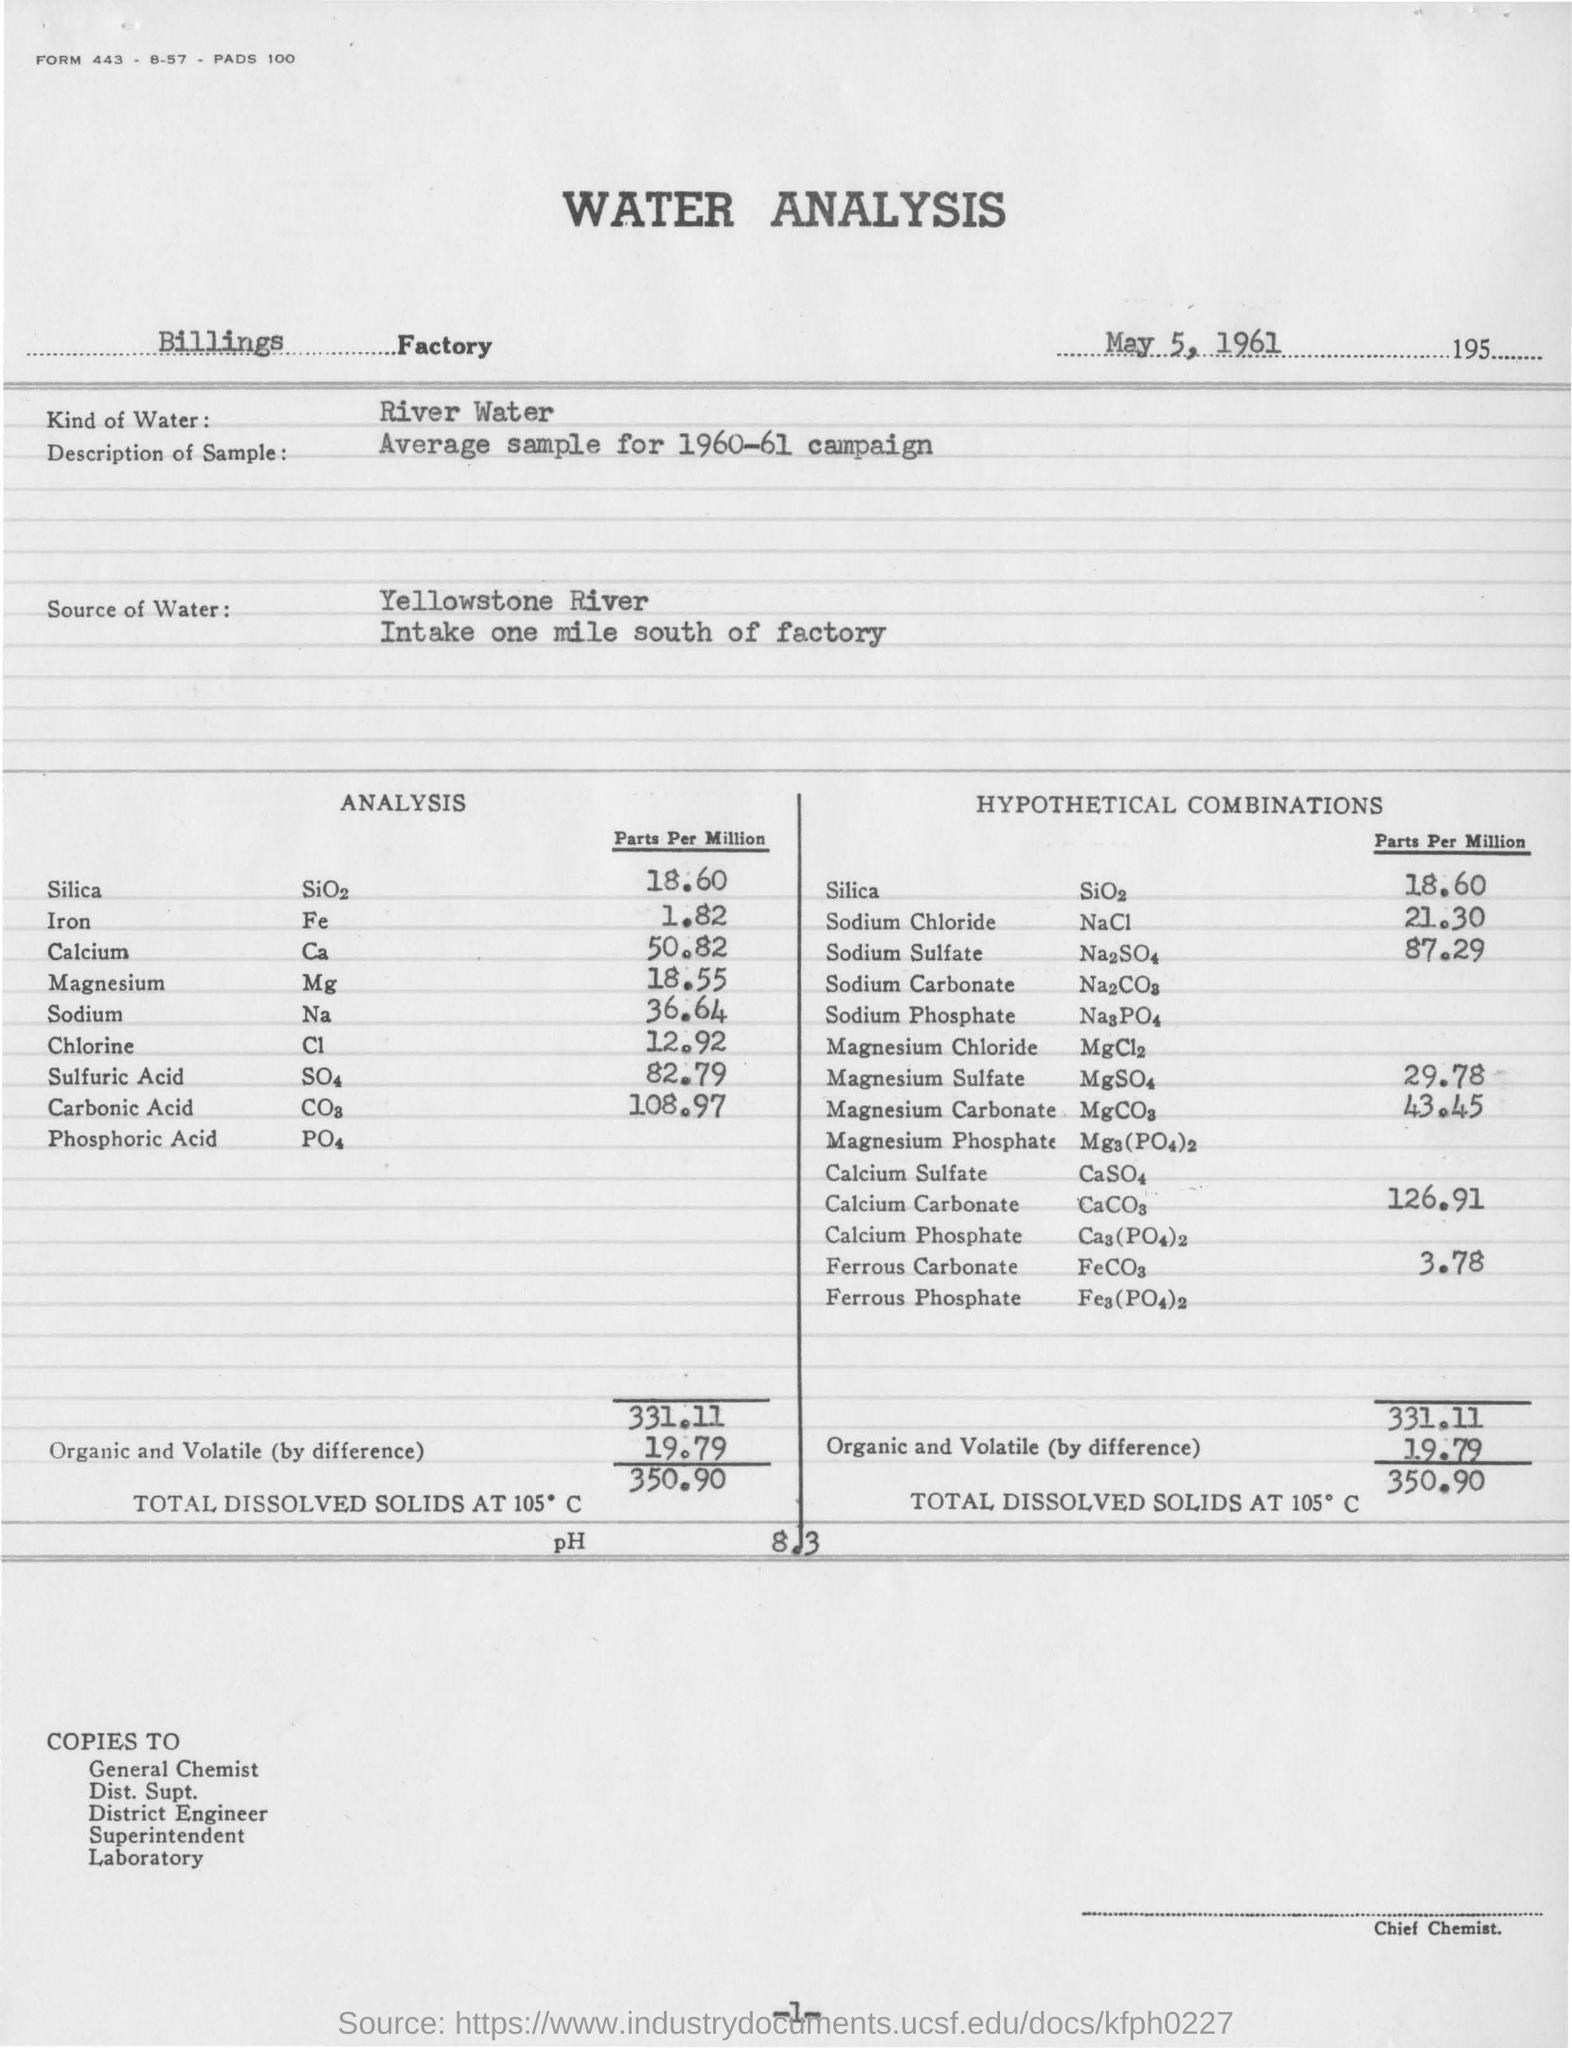What is heading of the document
Offer a terse response. WATER ANALYSIS. What is the kind of water
Your answer should be compact. River Water. Which river is the source of the water
Offer a terse response. Yellowstone River. As per analysis what is the silica parts per million
Ensure brevity in your answer.  18.60. What is the total dissolved solids at 105 degree celsius
Ensure brevity in your answer.  350.90. 